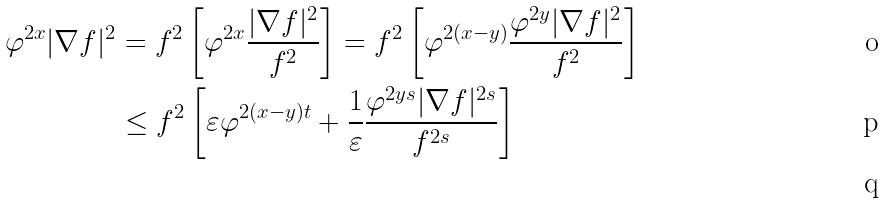<formula> <loc_0><loc_0><loc_500><loc_500>\varphi ^ { 2 x } | \nabla f | ^ { 2 } & = f ^ { 2 } \left [ \varphi ^ { 2 x } \frac { | \nabla f | ^ { 2 } } { f ^ { 2 } } \right ] = f ^ { 2 } \left [ \varphi ^ { 2 ( x - y ) } \frac { \varphi ^ { 2 y } | \nabla f | ^ { 2 } } { f ^ { 2 } } \right ] \\ & \leq f ^ { 2 } \left [ \varepsilon \varphi ^ { 2 ( x - y ) t } + \frac { 1 } { \varepsilon } \frac { \varphi ^ { 2 y s } | \nabla f | ^ { 2 s } } { f ^ { 2 s } } \right ] \\</formula> 